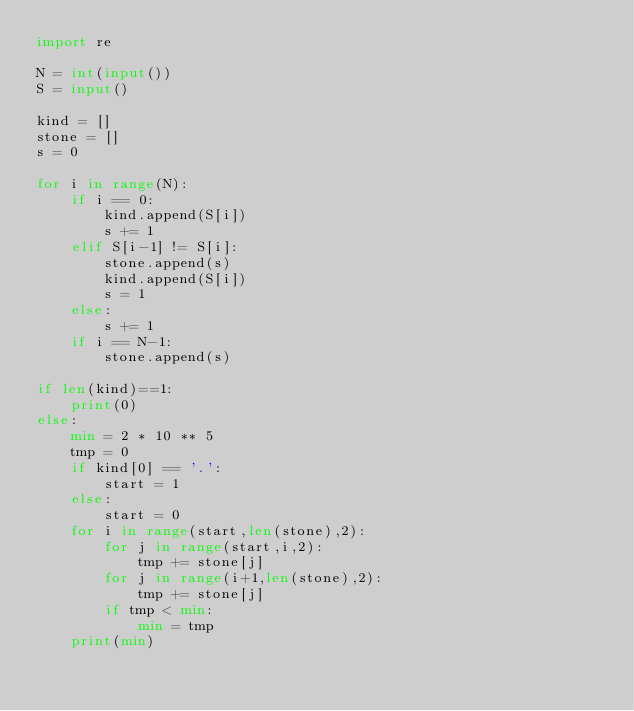Convert code to text. <code><loc_0><loc_0><loc_500><loc_500><_Python_>import re

N = int(input())
S = input()

kind = []
stone = []
s = 0

for i in range(N):
    if i == 0:
        kind.append(S[i])
        s += 1
    elif S[i-1] != S[i]:
        stone.append(s)
        kind.append(S[i])
        s = 1
    else:
        s += 1
    if i == N-1:
        stone.append(s)

if len(kind)==1:
    print(0)
else: 
    min = 2 * 10 ** 5
    tmp = 0
    if kind[0] == '.':
        start = 1
    else:
        start = 0
    for i in range(start,len(stone),2):
        for j in range(start,i,2):
            tmp += stone[j]
        for j in range(i+1,len(stone),2):
            tmp += stone[j]
        if tmp < min:
            min = tmp
    print(min)
</code> 